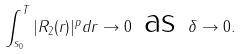Convert formula to latex. <formula><loc_0><loc_0><loc_500><loc_500>\int _ { s _ { 0 } } ^ { T } | R _ { 2 } ( r ) | ^ { p } d r \rightarrow 0 \text { as } \delta \rightarrow 0 .</formula> 